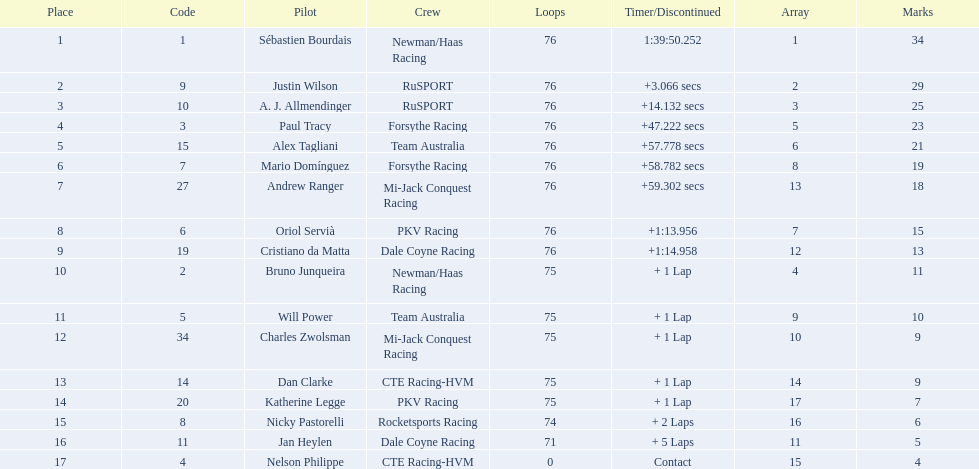How many points did charles zwolsman acquire? 9. Who else got 9 points? Dan Clarke. 